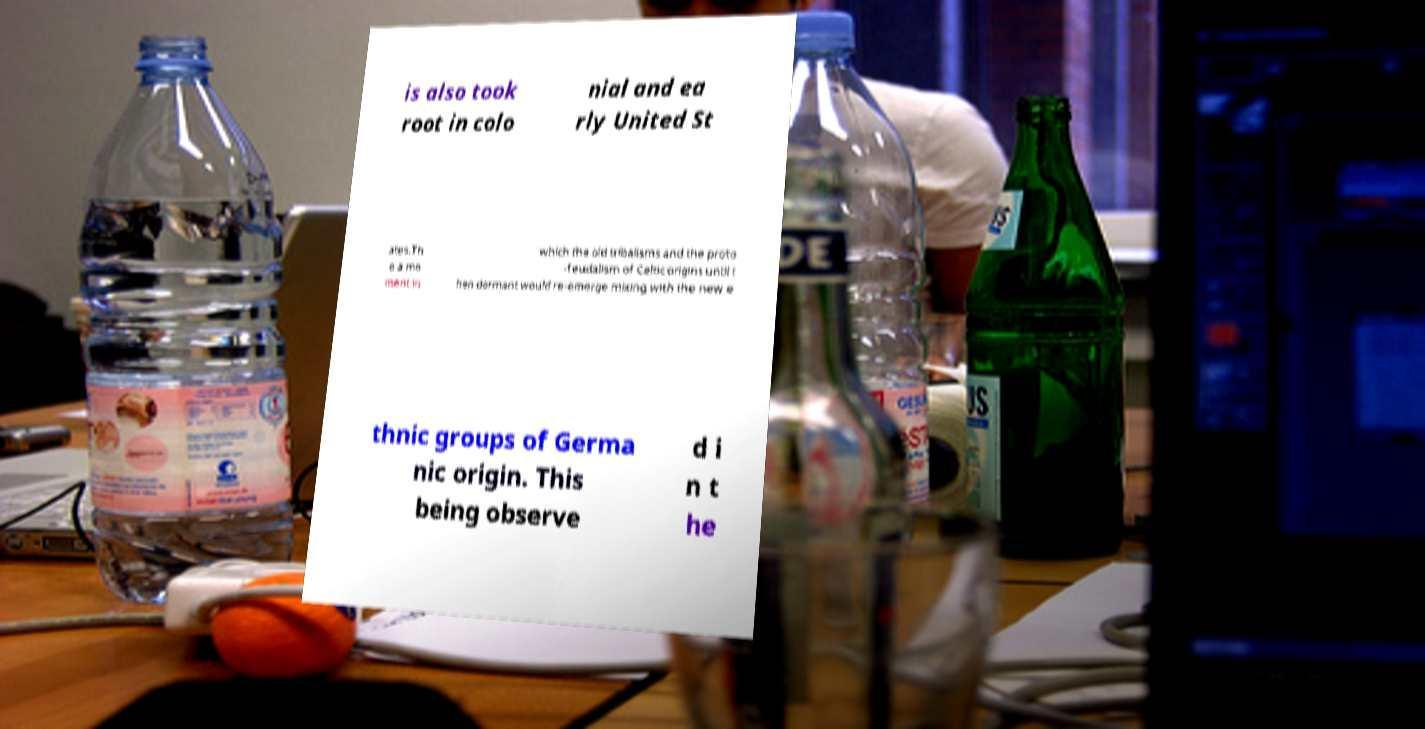Can you read and provide the text displayed in the image?This photo seems to have some interesting text. Can you extract and type it out for me? is also took root in colo nial and ea rly United St ates.Th e a mo ment in which the old tribalisms and the proto -feudalism of Celtic origins until t hen dormant would re-emerge mixing with the new e thnic groups of Germa nic origin. This being observe d i n t he 